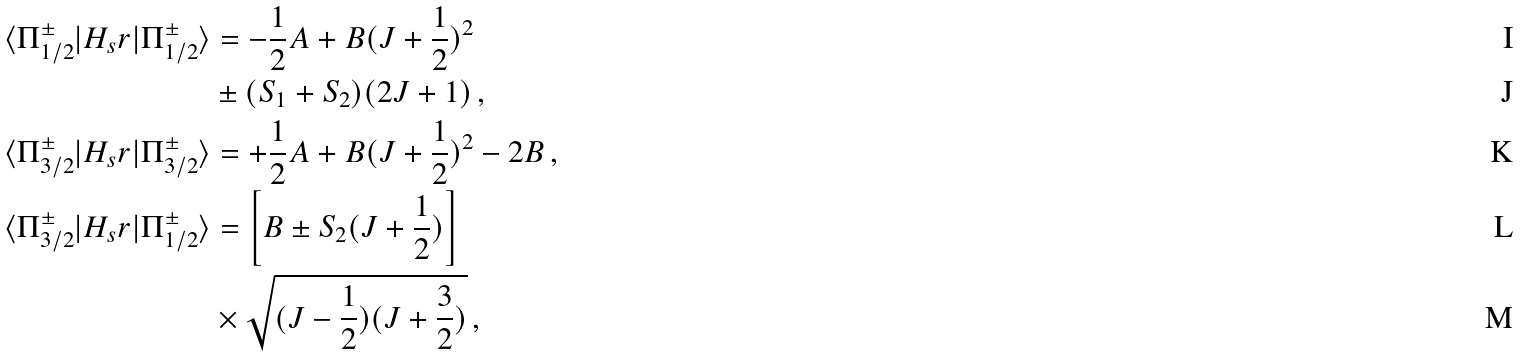Convert formula to latex. <formula><loc_0><loc_0><loc_500><loc_500>\langle \Pi _ { 1 / 2 } ^ { \pm } | H _ { s } r | \Pi _ { 1 / 2 } ^ { \pm } \rangle & = - \frac { 1 } { 2 } A + B ( J + \frac { 1 } { 2 } ) ^ { 2 } \\ & \pm ( S _ { 1 } + S _ { 2 } ) ( 2 J + 1 ) \, , \\ \langle \Pi _ { 3 / 2 } ^ { \pm } | H _ { s } r | \Pi _ { 3 / 2 } ^ { \pm } \rangle & = + \frac { 1 } { 2 } A + B ( J + \frac { 1 } { 2 } ) ^ { 2 } - 2 B \, , \\ \langle \Pi _ { 3 / 2 } ^ { \pm } | H _ { s } r | \Pi _ { 1 / 2 } ^ { \pm } \rangle & = \left [ B \pm S _ { 2 } ( J + \frac { 1 } { 2 } ) \right ] \\ & \times \sqrt { ( J - \frac { 1 } { 2 } ) ( J + \frac { 3 } { 2 } ) } \, ,</formula> 